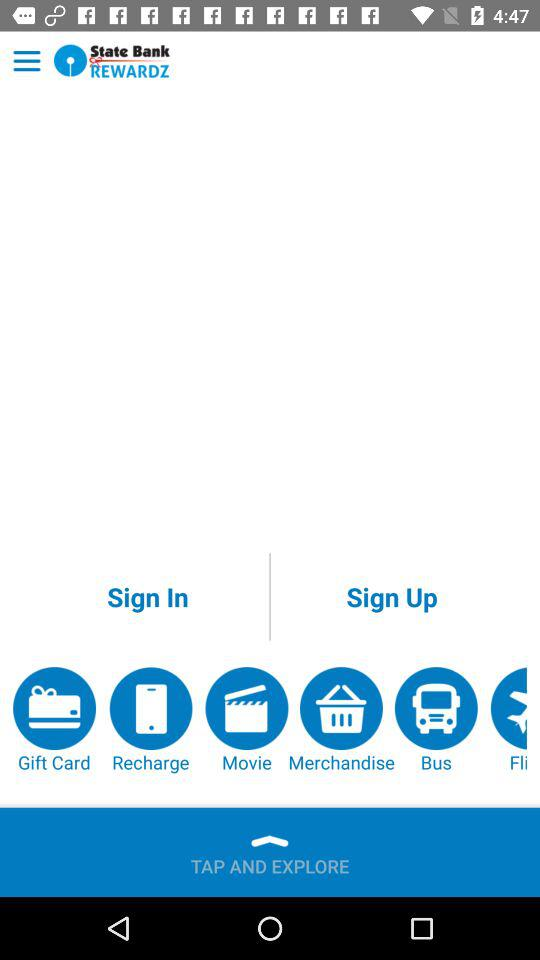How many notifications are there in "Merchandise"?
When the provided information is insufficient, respond with <no answer>. <no answer> 